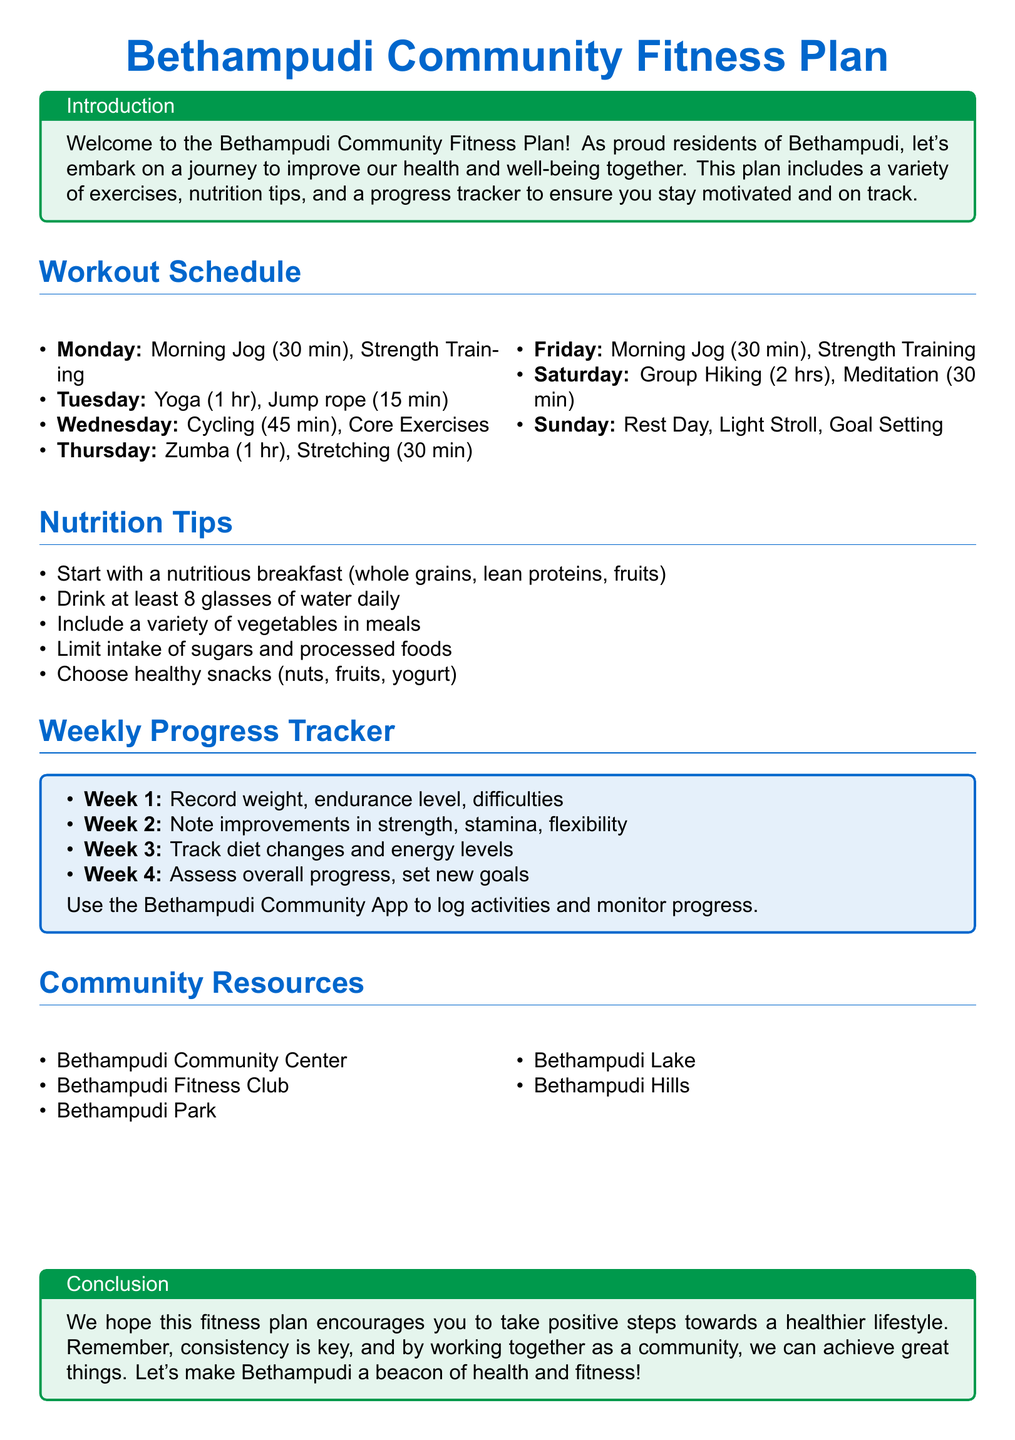What is the main purpose of the Bethampudi Community Fitness Plan? The introduction states that the purpose is to improve health and well-being together as a community.
Answer: Improve health and well-being How long is the morning jog scheduled for on Monday? The workout schedule specifies that the morning jog is for 30 minutes on Monday.
Answer: 30 min What type of exercise is included on Thursday? The workout schedule lists Zumba as the exercise for Thursday.
Answer: Zumba What goal is set for Week 4 in the progress tracker? Week 4 in the tracker indicates assessing overall progress and setting new goals.
Answer: Assess overall progress, set new goals What should be limited in the nutrition tips? The nutrition section advises limiting the intake of sugars and processed foods.
Answer: Sugars and processed foods Where can residents go for fitness activities listed in community resources? The community resources provide options such as Bethampudi Park for fitness activities.
Answer: Bethampudi Park How many hours are planned for Group Hiking on Saturday? The workout schedule states that Group Hiking is planned for 2 hours on Saturday.
Answer: 2 hrs What is advised to drink daily according to the nutrition tips? The nutrition section suggests drinking at least 8 glasses of water daily.
Answer: 8 glasses 